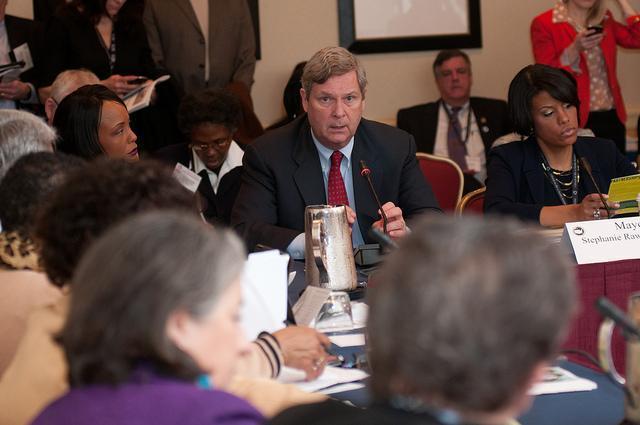How many people are there?
Give a very brief answer. 11. 